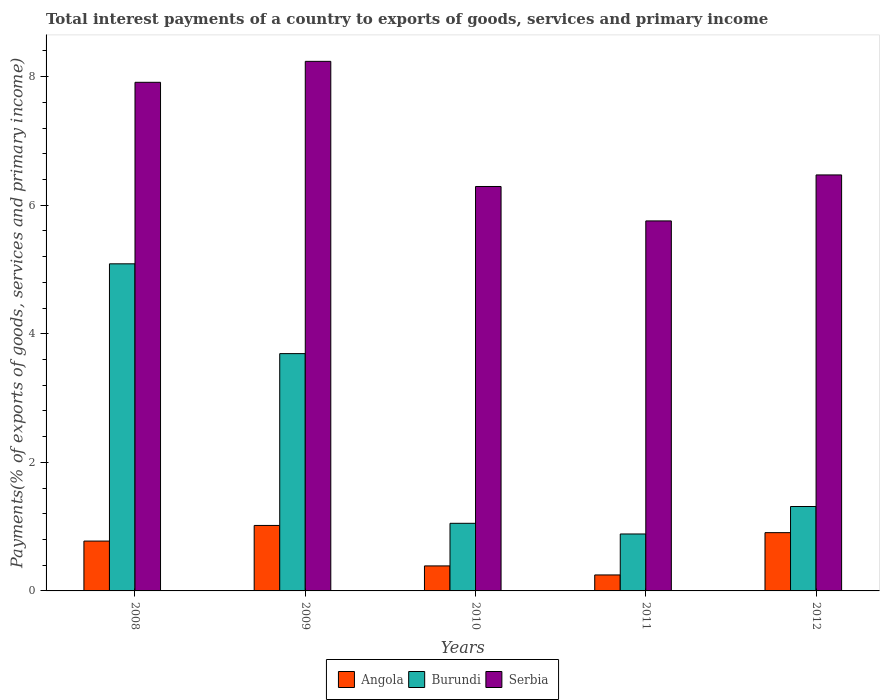Are the number of bars on each tick of the X-axis equal?
Make the answer very short. Yes. What is the label of the 4th group of bars from the left?
Your answer should be very brief. 2011. What is the total interest payments in Angola in 2009?
Your answer should be very brief. 1.02. Across all years, what is the maximum total interest payments in Angola?
Your answer should be very brief. 1.02. Across all years, what is the minimum total interest payments in Burundi?
Your answer should be very brief. 0.89. What is the total total interest payments in Angola in the graph?
Ensure brevity in your answer.  3.34. What is the difference between the total interest payments in Angola in 2009 and that in 2010?
Your answer should be compact. 0.63. What is the difference between the total interest payments in Serbia in 2009 and the total interest payments in Angola in 2012?
Your answer should be compact. 7.33. What is the average total interest payments in Burundi per year?
Keep it short and to the point. 2.41. In the year 2009, what is the difference between the total interest payments in Angola and total interest payments in Burundi?
Provide a succinct answer. -2.67. In how many years, is the total interest payments in Burundi greater than 1.2000000000000002 %?
Offer a terse response. 3. What is the ratio of the total interest payments in Serbia in 2008 to that in 2010?
Your answer should be compact. 1.26. What is the difference between the highest and the second highest total interest payments in Angola?
Your answer should be compact. 0.11. What is the difference between the highest and the lowest total interest payments in Burundi?
Make the answer very short. 4.2. What does the 3rd bar from the left in 2008 represents?
Your answer should be very brief. Serbia. What does the 2nd bar from the right in 2012 represents?
Offer a very short reply. Burundi. What is the difference between two consecutive major ticks on the Y-axis?
Keep it short and to the point. 2. How many legend labels are there?
Your response must be concise. 3. What is the title of the graph?
Give a very brief answer. Total interest payments of a country to exports of goods, services and primary income. Does "Kiribati" appear as one of the legend labels in the graph?
Keep it short and to the point. No. What is the label or title of the Y-axis?
Offer a terse response. Payments(% of exports of goods, services and primary income). What is the Payments(% of exports of goods, services and primary income) of Angola in 2008?
Your answer should be very brief. 0.78. What is the Payments(% of exports of goods, services and primary income) of Burundi in 2008?
Provide a short and direct response. 5.09. What is the Payments(% of exports of goods, services and primary income) of Serbia in 2008?
Offer a very short reply. 7.91. What is the Payments(% of exports of goods, services and primary income) in Angola in 2009?
Provide a short and direct response. 1.02. What is the Payments(% of exports of goods, services and primary income) of Burundi in 2009?
Your answer should be compact. 3.69. What is the Payments(% of exports of goods, services and primary income) of Serbia in 2009?
Offer a very short reply. 8.24. What is the Payments(% of exports of goods, services and primary income) of Angola in 2010?
Provide a succinct answer. 0.39. What is the Payments(% of exports of goods, services and primary income) in Burundi in 2010?
Your response must be concise. 1.05. What is the Payments(% of exports of goods, services and primary income) of Serbia in 2010?
Make the answer very short. 6.29. What is the Payments(% of exports of goods, services and primary income) of Angola in 2011?
Provide a succinct answer. 0.25. What is the Payments(% of exports of goods, services and primary income) in Burundi in 2011?
Keep it short and to the point. 0.89. What is the Payments(% of exports of goods, services and primary income) in Serbia in 2011?
Provide a succinct answer. 5.76. What is the Payments(% of exports of goods, services and primary income) in Angola in 2012?
Offer a very short reply. 0.91. What is the Payments(% of exports of goods, services and primary income) in Burundi in 2012?
Provide a succinct answer. 1.31. What is the Payments(% of exports of goods, services and primary income) of Serbia in 2012?
Offer a very short reply. 6.47. Across all years, what is the maximum Payments(% of exports of goods, services and primary income) in Angola?
Your response must be concise. 1.02. Across all years, what is the maximum Payments(% of exports of goods, services and primary income) of Burundi?
Offer a terse response. 5.09. Across all years, what is the maximum Payments(% of exports of goods, services and primary income) in Serbia?
Ensure brevity in your answer.  8.24. Across all years, what is the minimum Payments(% of exports of goods, services and primary income) of Angola?
Your answer should be compact. 0.25. Across all years, what is the minimum Payments(% of exports of goods, services and primary income) of Burundi?
Your response must be concise. 0.89. Across all years, what is the minimum Payments(% of exports of goods, services and primary income) of Serbia?
Provide a short and direct response. 5.76. What is the total Payments(% of exports of goods, services and primary income) of Angola in the graph?
Provide a succinct answer. 3.34. What is the total Payments(% of exports of goods, services and primary income) in Burundi in the graph?
Keep it short and to the point. 12.03. What is the total Payments(% of exports of goods, services and primary income) in Serbia in the graph?
Your answer should be very brief. 34.67. What is the difference between the Payments(% of exports of goods, services and primary income) of Angola in 2008 and that in 2009?
Offer a very short reply. -0.24. What is the difference between the Payments(% of exports of goods, services and primary income) of Burundi in 2008 and that in 2009?
Keep it short and to the point. 1.4. What is the difference between the Payments(% of exports of goods, services and primary income) in Serbia in 2008 and that in 2009?
Give a very brief answer. -0.33. What is the difference between the Payments(% of exports of goods, services and primary income) of Angola in 2008 and that in 2010?
Your answer should be very brief. 0.39. What is the difference between the Payments(% of exports of goods, services and primary income) of Burundi in 2008 and that in 2010?
Provide a short and direct response. 4.04. What is the difference between the Payments(% of exports of goods, services and primary income) in Serbia in 2008 and that in 2010?
Ensure brevity in your answer.  1.62. What is the difference between the Payments(% of exports of goods, services and primary income) in Angola in 2008 and that in 2011?
Offer a very short reply. 0.53. What is the difference between the Payments(% of exports of goods, services and primary income) in Burundi in 2008 and that in 2011?
Offer a very short reply. 4.2. What is the difference between the Payments(% of exports of goods, services and primary income) in Serbia in 2008 and that in 2011?
Make the answer very short. 2.16. What is the difference between the Payments(% of exports of goods, services and primary income) of Angola in 2008 and that in 2012?
Provide a short and direct response. -0.13. What is the difference between the Payments(% of exports of goods, services and primary income) in Burundi in 2008 and that in 2012?
Provide a short and direct response. 3.78. What is the difference between the Payments(% of exports of goods, services and primary income) in Serbia in 2008 and that in 2012?
Ensure brevity in your answer.  1.44. What is the difference between the Payments(% of exports of goods, services and primary income) of Angola in 2009 and that in 2010?
Give a very brief answer. 0.63. What is the difference between the Payments(% of exports of goods, services and primary income) of Burundi in 2009 and that in 2010?
Your answer should be compact. 2.64. What is the difference between the Payments(% of exports of goods, services and primary income) in Serbia in 2009 and that in 2010?
Keep it short and to the point. 1.95. What is the difference between the Payments(% of exports of goods, services and primary income) of Angola in 2009 and that in 2011?
Ensure brevity in your answer.  0.77. What is the difference between the Payments(% of exports of goods, services and primary income) in Burundi in 2009 and that in 2011?
Provide a succinct answer. 2.81. What is the difference between the Payments(% of exports of goods, services and primary income) of Serbia in 2009 and that in 2011?
Provide a succinct answer. 2.48. What is the difference between the Payments(% of exports of goods, services and primary income) of Angola in 2009 and that in 2012?
Give a very brief answer. 0.11. What is the difference between the Payments(% of exports of goods, services and primary income) of Burundi in 2009 and that in 2012?
Provide a short and direct response. 2.38. What is the difference between the Payments(% of exports of goods, services and primary income) in Serbia in 2009 and that in 2012?
Your answer should be very brief. 1.77. What is the difference between the Payments(% of exports of goods, services and primary income) in Angola in 2010 and that in 2011?
Your response must be concise. 0.14. What is the difference between the Payments(% of exports of goods, services and primary income) in Burundi in 2010 and that in 2011?
Make the answer very short. 0.17. What is the difference between the Payments(% of exports of goods, services and primary income) of Serbia in 2010 and that in 2011?
Provide a short and direct response. 0.54. What is the difference between the Payments(% of exports of goods, services and primary income) of Angola in 2010 and that in 2012?
Provide a short and direct response. -0.52. What is the difference between the Payments(% of exports of goods, services and primary income) of Burundi in 2010 and that in 2012?
Make the answer very short. -0.26. What is the difference between the Payments(% of exports of goods, services and primary income) of Serbia in 2010 and that in 2012?
Your answer should be compact. -0.18. What is the difference between the Payments(% of exports of goods, services and primary income) in Angola in 2011 and that in 2012?
Your answer should be compact. -0.66. What is the difference between the Payments(% of exports of goods, services and primary income) in Burundi in 2011 and that in 2012?
Provide a succinct answer. -0.43. What is the difference between the Payments(% of exports of goods, services and primary income) of Serbia in 2011 and that in 2012?
Offer a very short reply. -0.72. What is the difference between the Payments(% of exports of goods, services and primary income) of Angola in 2008 and the Payments(% of exports of goods, services and primary income) of Burundi in 2009?
Offer a very short reply. -2.92. What is the difference between the Payments(% of exports of goods, services and primary income) of Angola in 2008 and the Payments(% of exports of goods, services and primary income) of Serbia in 2009?
Your answer should be compact. -7.46. What is the difference between the Payments(% of exports of goods, services and primary income) in Burundi in 2008 and the Payments(% of exports of goods, services and primary income) in Serbia in 2009?
Your response must be concise. -3.15. What is the difference between the Payments(% of exports of goods, services and primary income) of Angola in 2008 and the Payments(% of exports of goods, services and primary income) of Burundi in 2010?
Ensure brevity in your answer.  -0.28. What is the difference between the Payments(% of exports of goods, services and primary income) of Angola in 2008 and the Payments(% of exports of goods, services and primary income) of Serbia in 2010?
Provide a short and direct response. -5.52. What is the difference between the Payments(% of exports of goods, services and primary income) in Burundi in 2008 and the Payments(% of exports of goods, services and primary income) in Serbia in 2010?
Ensure brevity in your answer.  -1.2. What is the difference between the Payments(% of exports of goods, services and primary income) of Angola in 2008 and the Payments(% of exports of goods, services and primary income) of Burundi in 2011?
Offer a terse response. -0.11. What is the difference between the Payments(% of exports of goods, services and primary income) of Angola in 2008 and the Payments(% of exports of goods, services and primary income) of Serbia in 2011?
Keep it short and to the point. -4.98. What is the difference between the Payments(% of exports of goods, services and primary income) of Burundi in 2008 and the Payments(% of exports of goods, services and primary income) of Serbia in 2011?
Offer a terse response. -0.67. What is the difference between the Payments(% of exports of goods, services and primary income) of Angola in 2008 and the Payments(% of exports of goods, services and primary income) of Burundi in 2012?
Make the answer very short. -0.54. What is the difference between the Payments(% of exports of goods, services and primary income) of Angola in 2008 and the Payments(% of exports of goods, services and primary income) of Serbia in 2012?
Provide a succinct answer. -5.7. What is the difference between the Payments(% of exports of goods, services and primary income) in Burundi in 2008 and the Payments(% of exports of goods, services and primary income) in Serbia in 2012?
Provide a succinct answer. -1.38. What is the difference between the Payments(% of exports of goods, services and primary income) of Angola in 2009 and the Payments(% of exports of goods, services and primary income) of Burundi in 2010?
Make the answer very short. -0.03. What is the difference between the Payments(% of exports of goods, services and primary income) of Angola in 2009 and the Payments(% of exports of goods, services and primary income) of Serbia in 2010?
Your answer should be compact. -5.27. What is the difference between the Payments(% of exports of goods, services and primary income) of Burundi in 2009 and the Payments(% of exports of goods, services and primary income) of Serbia in 2010?
Provide a short and direct response. -2.6. What is the difference between the Payments(% of exports of goods, services and primary income) in Angola in 2009 and the Payments(% of exports of goods, services and primary income) in Burundi in 2011?
Keep it short and to the point. 0.13. What is the difference between the Payments(% of exports of goods, services and primary income) of Angola in 2009 and the Payments(% of exports of goods, services and primary income) of Serbia in 2011?
Your response must be concise. -4.74. What is the difference between the Payments(% of exports of goods, services and primary income) in Burundi in 2009 and the Payments(% of exports of goods, services and primary income) in Serbia in 2011?
Your response must be concise. -2.06. What is the difference between the Payments(% of exports of goods, services and primary income) in Angola in 2009 and the Payments(% of exports of goods, services and primary income) in Burundi in 2012?
Keep it short and to the point. -0.29. What is the difference between the Payments(% of exports of goods, services and primary income) in Angola in 2009 and the Payments(% of exports of goods, services and primary income) in Serbia in 2012?
Your response must be concise. -5.45. What is the difference between the Payments(% of exports of goods, services and primary income) of Burundi in 2009 and the Payments(% of exports of goods, services and primary income) of Serbia in 2012?
Offer a very short reply. -2.78. What is the difference between the Payments(% of exports of goods, services and primary income) in Angola in 2010 and the Payments(% of exports of goods, services and primary income) in Burundi in 2011?
Give a very brief answer. -0.5. What is the difference between the Payments(% of exports of goods, services and primary income) in Angola in 2010 and the Payments(% of exports of goods, services and primary income) in Serbia in 2011?
Ensure brevity in your answer.  -5.37. What is the difference between the Payments(% of exports of goods, services and primary income) in Burundi in 2010 and the Payments(% of exports of goods, services and primary income) in Serbia in 2011?
Provide a short and direct response. -4.7. What is the difference between the Payments(% of exports of goods, services and primary income) in Angola in 2010 and the Payments(% of exports of goods, services and primary income) in Burundi in 2012?
Ensure brevity in your answer.  -0.92. What is the difference between the Payments(% of exports of goods, services and primary income) in Angola in 2010 and the Payments(% of exports of goods, services and primary income) in Serbia in 2012?
Provide a short and direct response. -6.08. What is the difference between the Payments(% of exports of goods, services and primary income) in Burundi in 2010 and the Payments(% of exports of goods, services and primary income) in Serbia in 2012?
Ensure brevity in your answer.  -5.42. What is the difference between the Payments(% of exports of goods, services and primary income) of Angola in 2011 and the Payments(% of exports of goods, services and primary income) of Burundi in 2012?
Your answer should be very brief. -1.06. What is the difference between the Payments(% of exports of goods, services and primary income) of Angola in 2011 and the Payments(% of exports of goods, services and primary income) of Serbia in 2012?
Give a very brief answer. -6.22. What is the difference between the Payments(% of exports of goods, services and primary income) in Burundi in 2011 and the Payments(% of exports of goods, services and primary income) in Serbia in 2012?
Make the answer very short. -5.59. What is the average Payments(% of exports of goods, services and primary income) in Angola per year?
Give a very brief answer. 0.67. What is the average Payments(% of exports of goods, services and primary income) in Burundi per year?
Make the answer very short. 2.41. What is the average Payments(% of exports of goods, services and primary income) of Serbia per year?
Keep it short and to the point. 6.93. In the year 2008, what is the difference between the Payments(% of exports of goods, services and primary income) of Angola and Payments(% of exports of goods, services and primary income) of Burundi?
Give a very brief answer. -4.31. In the year 2008, what is the difference between the Payments(% of exports of goods, services and primary income) of Angola and Payments(% of exports of goods, services and primary income) of Serbia?
Your response must be concise. -7.14. In the year 2008, what is the difference between the Payments(% of exports of goods, services and primary income) of Burundi and Payments(% of exports of goods, services and primary income) of Serbia?
Make the answer very short. -2.82. In the year 2009, what is the difference between the Payments(% of exports of goods, services and primary income) in Angola and Payments(% of exports of goods, services and primary income) in Burundi?
Your answer should be very brief. -2.67. In the year 2009, what is the difference between the Payments(% of exports of goods, services and primary income) in Angola and Payments(% of exports of goods, services and primary income) in Serbia?
Give a very brief answer. -7.22. In the year 2009, what is the difference between the Payments(% of exports of goods, services and primary income) of Burundi and Payments(% of exports of goods, services and primary income) of Serbia?
Your answer should be compact. -4.55. In the year 2010, what is the difference between the Payments(% of exports of goods, services and primary income) of Angola and Payments(% of exports of goods, services and primary income) of Burundi?
Make the answer very short. -0.66. In the year 2010, what is the difference between the Payments(% of exports of goods, services and primary income) in Angola and Payments(% of exports of goods, services and primary income) in Serbia?
Make the answer very short. -5.9. In the year 2010, what is the difference between the Payments(% of exports of goods, services and primary income) in Burundi and Payments(% of exports of goods, services and primary income) in Serbia?
Your response must be concise. -5.24. In the year 2011, what is the difference between the Payments(% of exports of goods, services and primary income) of Angola and Payments(% of exports of goods, services and primary income) of Burundi?
Your answer should be compact. -0.64. In the year 2011, what is the difference between the Payments(% of exports of goods, services and primary income) of Angola and Payments(% of exports of goods, services and primary income) of Serbia?
Your answer should be compact. -5.51. In the year 2011, what is the difference between the Payments(% of exports of goods, services and primary income) in Burundi and Payments(% of exports of goods, services and primary income) in Serbia?
Offer a very short reply. -4.87. In the year 2012, what is the difference between the Payments(% of exports of goods, services and primary income) in Angola and Payments(% of exports of goods, services and primary income) in Burundi?
Make the answer very short. -0.41. In the year 2012, what is the difference between the Payments(% of exports of goods, services and primary income) of Angola and Payments(% of exports of goods, services and primary income) of Serbia?
Your answer should be compact. -5.57. In the year 2012, what is the difference between the Payments(% of exports of goods, services and primary income) in Burundi and Payments(% of exports of goods, services and primary income) in Serbia?
Provide a short and direct response. -5.16. What is the ratio of the Payments(% of exports of goods, services and primary income) in Angola in 2008 to that in 2009?
Give a very brief answer. 0.76. What is the ratio of the Payments(% of exports of goods, services and primary income) of Burundi in 2008 to that in 2009?
Provide a succinct answer. 1.38. What is the ratio of the Payments(% of exports of goods, services and primary income) of Serbia in 2008 to that in 2009?
Provide a succinct answer. 0.96. What is the ratio of the Payments(% of exports of goods, services and primary income) of Angola in 2008 to that in 2010?
Make the answer very short. 1.99. What is the ratio of the Payments(% of exports of goods, services and primary income) in Burundi in 2008 to that in 2010?
Make the answer very short. 4.84. What is the ratio of the Payments(% of exports of goods, services and primary income) in Serbia in 2008 to that in 2010?
Provide a succinct answer. 1.26. What is the ratio of the Payments(% of exports of goods, services and primary income) in Angola in 2008 to that in 2011?
Offer a very short reply. 3.12. What is the ratio of the Payments(% of exports of goods, services and primary income) in Burundi in 2008 to that in 2011?
Ensure brevity in your answer.  5.74. What is the ratio of the Payments(% of exports of goods, services and primary income) of Serbia in 2008 to that in 2011?
Provide a succinct answer. 1.37. What is the ratio of the Payments(% of exports of goods, services and primary income) in Angola in 2008 to that in 2012?
Give a very brief answer. 0.86. What is the ratio of the Payments(% of exports of goods, services and primary income) in Burundi in 2008 to that in 2012?
Your answer should be compact. 3.88. What is the ratio of the Payments(% of exports of goods, services and primary income) of Serbia in 2008 to that in 2012?
Provide a short and direct response. 1.22. What is the ratio of the Payments(% of exports of goods, services and primary income) in Angola in 2009 to that in 2010?
Offer a terse response. 2.62. What is the ratio of the Payments(% of exports of goods, services and primary income) in Burundi in 2009 to that in 2010?
Offer a terse response. 3.51. What is the ratio of the Payments(% of exports of goods, services and primary income) of Serbia in 2009 to that in 2010?
Provide a succinct answer. 1.31. What is the ratio of the Payments(% of exports of goods, services and primary income) of Angola in 2009 to that in 2011?
Keep it short and to the point. 4.1. What is the ratio of the Payments(% of exports of goods, services and primary income) of Burundi in 2009 to that in 2011?
Your response must be concise. 4.17. What is the ratio of the Payments(% of exports of goods, services and primary income) in Serbia in 2009 to that in 2011?
Offer a very short reply. 1.43. What is the ratio of the Payments(% of exports of goods, services and primary income) of Angola in 2009 to that in 2012?
Your answer should be very brief. 1.12. What is the ratio of the Payments(% of exports of goods, services and primary income) in Burundi in 2009 to that in 2012?
Offer a very short reply. 2.81. What is the ratio of the Payments(% of exports of goods, services and primary income) of Serbia in 2009 to that in 2012?
Your answer should be very brief. 1.27. What is the ratio of the Payments(% of exports of goods, services and primary income) in Angola in 2010 to that in 2011?
Your answer should be very brief. 1.57. What is the ratio of the Payments(% of exports of goods, services and primary income) in Burundi in 2010 to that in 2011?
Ensure brevity in your answer.  1.19. What is the ratio of the Payments(% of exports of goods, services and primary income) in Serbia in 2010 to that in 2011?
Offer a terse response. 1.09. What is the ratio of the Payments(% of exports of goods, services and primary income) of Angola in 2010 to that in 2012?
Make the answer very short. 0.43. What is the ratio of the Payments(% of exports of goods, services and primary income) of Burundi in 2010 to that in 2012?
Provide a short and direct response. 0.8. What is the ratio of the Payments(% of exports of goods, services and primary income) of Serbia in 2010 to that in 2012?
Your answer should be very brief. 0.97. What is the ratio of the Payments(% of exports of goods, services and primary income) in Angola in 2011 to that in 2012?
Provide a short and direct response. 0.27. What is the ratio of the Payments(% of exports of goods, services and primary income) of Burundi in 2011 to that in 2012?
Make the answer very short. 0.67. What is the ratio of the Payments(% of exports of goods, services and primary income) of Serbia in 2011 to that in 2012?
Provide a short and direct response. 0.89. What is the difference between the highest and the second highest Payments(% of exports of goods, services and primary income) of Angola?
Offer a terse response. 0.11. What is the difference between the highest and the second highest Payments(% of exports of goods, services and primary income) of Burundi?
Offer a very short reply. 1.4. What is the difference between the highest and the second highest Payments(% of exports of goods, services and primary income) in Serbia?
Ensure brevity in your answer.  0.33. What is the difference between the highest and the lowest Payments(% of exports of goods, services and primary income) in Angola?
Your response must be concise. 0.77. What is the difference between the highest and the lowest Payments(% of exports of goods, services and primary income) in Burundi?
Your answer should be very brief. 4.2. What is the difference between the highest and the lowest Payments(% of exports of goods, services and primary income) of Serbia?
Provide a succinct answer. 2.48. 